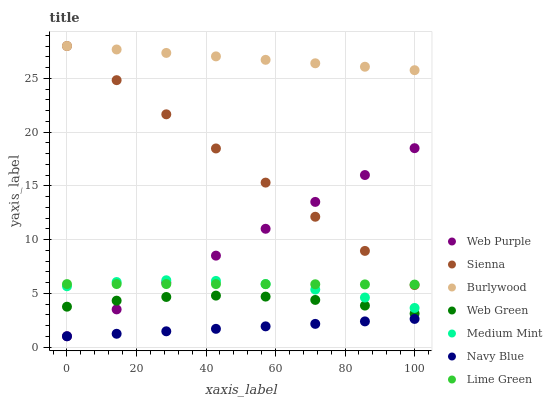Does Navy Blue have the minimum area under the curve?
Answer yes or no. Yes. Does Burlywood have the maximum area under the curve?
Answer yes or no. Yes. Does Burlywood have the minimum area under the curve?
Answer yes or no. No. Does Navy Blue have the maximum area under the curve?
Answer yes or no. No. Is Burlywood the smoothest?
Answer yes or no. Yes. Is Medium Mint the roughest?
Answer yes or no. Yes. Is Navy Blue the smoothest?
Answer yes or no. No. Is Navy Blue the roughest?
Answer yes or no. No. Does Navy Blue have the lowest value?
Answer yes or no. Yes. Does Burlywood have the lowest value?
Answer yes or no. No. Does Sienna have the highest value?
Answer yes or no. Yes. Does Navy Blue have the highest value?
Answer yes or no. No. Is Lime Green less than Burlywood?
Answer yes or no. Yes. Is Burlywood greater than Web Purple?
Answer yes or no. Yes. Does Web Purple intersect Sienna?
Answer yes or no. Yes. Is Web Purple less than Sienna?
Answer yes or no. No. Is Web Purple greater than Sienna?
Answer yes or no. No. Does Lime Green intersect Burlywood?
Answer yes or no. No. 